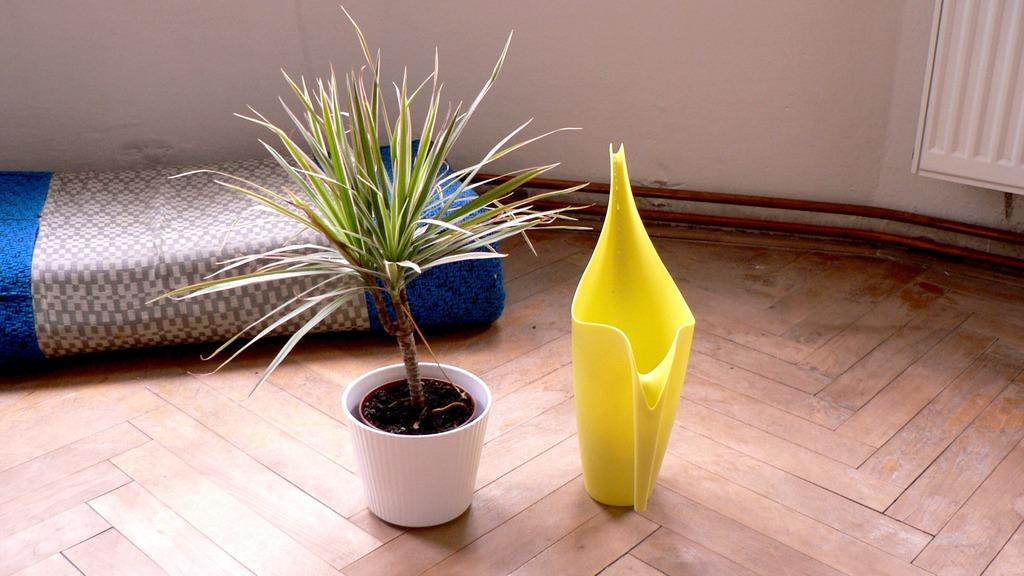What type of plant is in the pot in the image? The facts do not specify the type of plant in the pot. What is located on the right side of the image? There is a water jar on the right side of the image. What can be seen in the backdrop of the image? There is a mat in the backdrop of the image. What is the background of the image made of? There is a wall in the image, which serves as the background. What type of silverware is visible in the image? There is no silverware present in the image. What type of space-related objects can be seen in the image? There are no space-related objects present in the image. 